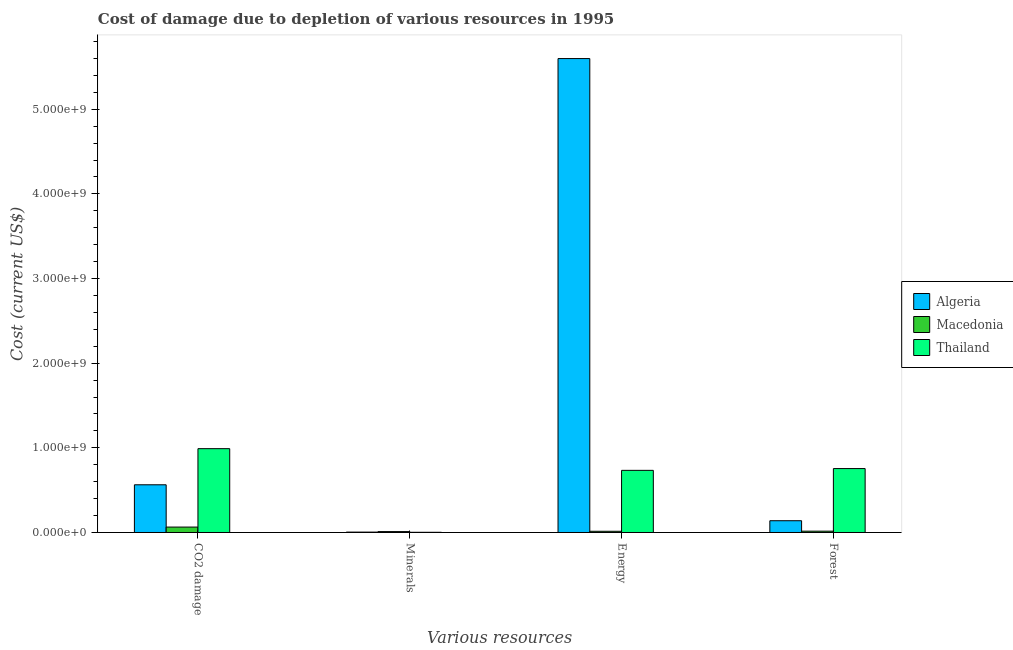How many different coloured bars are there?
Provide a succinct answer. 3. Are the number of bars per tick equal to the number of legend labels?
Your response must be concise. Yes. Are the number of bars on each tick of the X-axis equal?
Offer a very short reply. Yes. How many bars are there on the 4th tick from the right?
Offer a terse response. 3. What is the label of the 1st group of bars from the left?
Your answer should be very brief. CO2 damage. What is the cost of damage due to depletion of minerals in Algeria?
Give a very brief answer. 4.58e+06. Across all countries, what is the maximum cost of damage due to depletion of minerals?
Ensure brevity in your answer.  1.07e+07. Across all countries, what is the minimum cost of damage due to depletion of minerals?
Your response must be concise. 2.41e+06. In which country was the cost of damage due to depletion of minerals maximum?
Offer a terse response. Macedonia. In which country was the cost of damage due to depletion of energy minimum?
Your response must be concise. Macedonia. What is the total cost of damage due to depletion of minerals in the graph?
Provide a short and direct response. 1.76e+07. What is the difference between the cost of damage due to depletion of forests in Thailand and that in Algeria?
Provide a short and direct response. 6.16e+08. What is the difference between the cost of damage due to depletion of energy in Thailand and the cost of damage due to depletion of coal in Algeria?
Offer a terse response. 1.71e+08. What is the average cost of damage due to depletion of minerals per country?
Offer a very short reply. 5.88e+06. What is the difference between the cost of damage due to depletion of coal and cost of damage due to depletion of minerals in Thailand?
Keep it short and to the point. 9.88e+08. What is the ratio of the cost of damage due to depletion of minerals in Thailand to that in Algeria?
Your response must be concise. 0.53. Is the difference between the cost of damage due to depletion of minerals in Algeria and Macedonia greater than the difference between the cost of damage due to depletion of energy in Algeria and Macedonia?
Provide a short and direct response. No. What is the difference between the highest and the second highest cost of damage due to depletion of minerals?
Your answer should be compact. 6.08e+06. What is the difference between the highest and the lowest cost of damage due to depletion of coal?
Your response must be concise. 9.26e+08. Is the sum of the cost of damage due to depletion of forests in Thailand and Macedonia greater than the maximum cost of damage due to depletion of minerals across all countries?
Offer a very short reply. Yes. What does the 3rd bar from the left in Forest represents?
Offer a terse response. Thailand. What does the 2nd bar from the right in Energy represents?
Provide a succinct answer. Macedonia. Are all the bars in the graph horizontal?
Provide a succinct answer. No. How many countries are there in the graph?
Offer a terse response. 3. Are the values on the major ticks of Y-axis written in scientific E-notation?
Your response must be concise. Yes. Where does the legend appear in the graph?
Ensure brevity in your answer.  Center right. What is the title of the graph?
Offer a very short reply. Cost of damage due to depletion of various resources in 1995 . Does "Solomon Islands" appear as one of the legend labels in the graph?
Your response must be concise. No. What is the label or title of the X-axis?
Keep it short and to the point. Various resources. What is the label or title of the Y-axis?
Offer a very short reply. Cost (current US$). What is the Cost (current US$) in Algeria in CO2 damage?
Make the answer very short. 5.63e+08. What is the Cost (current US$) of Macedonia in CO2 damage?
Your response must be concise. 6.41e+07. What is the Cost (current US$) in Thailand in CO2 damage?
Ensure brevity in your answer.  9.90e+08. What is the Cost (current US$) in Algeria in Minerals?
Keep it short and to the point. 4.58e+06. What is the Cost (current US$) of Macedonia in Minerals?
Provide a short and direct response. 1.07e+07. What is the Cost (current US$) of Thailand in Minerals?
Provide a succinct answer. 2.41e+06. What is the Cost (current US$) in Algeria in Energy?
Ensure brevity in your answer.  5.60e+09. What is the Cost (current US$) of Macedonia in Energy?
Provide a short and direct response. 1.43e+07. What is the Cost (current US$) of Thailand in Energy?
Provide a short and direct response. 7.34e+08. What is the Cost (current US$) of Algeria in Forest?
Your answer should be compact. 1.39e+08. What is the Cost (current US$) of Macedonia in Forest?
Ensure brevity in your answer.  1.57e+07. What is the Cost (current US$) of Thailand in Forest?
Your answer should be compact. 7.55e+08. Across all Various resources, what is the maximum Cost (current US$) in Algeria?
Your answer should be very brief. 5.60e+09. Across all Various resources, what is the maximum Cost (current US$) in Macedonia?
Give a very brief answer. 6.41e+07. Across all Various resources, what is the maximum Cost (current US$) in Thailand?
Make the answer very short. 9.90e+08. Across all Various resources, what is the minimum Cost (current US$) in Algeria?
Provide a succinct answer. 4.58e+06. Across all Various resources, what is the minimum Cost (current US$) of Macedonia?
Provide a succinct answer. 1.07e+07. Across all Various resources, what is the minimum Cost (current US$) of Thailand?
Make the answer very short. 2.41e+06. What is the total Cost (current US$) in Algeria in the graph?
Your answer should be compact. 6.31e+09. What is the total Cost (current US$) in Macedonia in the graph?
Your answer should be compact. 1.05e+08. What is the total Cost (current US$) of Thailand in the graph?
Keep it short and to the point. 2.48e+09. What is the difference between the Cost (current US$) of Algeria in CO2 damage and that in Minerals?
Ensure brevity in your answer.  5.59e+08. What is the difference between the Cost (current US$) in Macedonia in CO2 damage and that in Minerals?
Offer a terse response. 5.34e+07. What is the difference between the Cost (current US$) of Thailand in CO2 damage and that in Minerals?
Your answer should be very brief. 9.88e+08. What is the difference between the Cost (current US$) of Algeria in CO2 damage and that in Energy?
Offer a terse response. -5.04e+09. What is the difference between the Cost (current US$) in Macedonia in CO2 damage and that in Energy?
Keep it short and to the point. 4.98e+07. What is the difference between the Cost (current US$) in Thailand in CO2 damage and that in Energy?
Your response must be concise. 2.56e+08. What is the difference between the Cost (current US$) in Algeria in CO2 damage and that in Forest?
Your response must be concise. 4.24e+08. What is the difference between the Cost (current US$) in Macedonia in CO2 damage and that in Forest?
Offer a very short reply. 4.84e+07. What is the difference between the Cost (current US$) in Thailand in CO2 damage and that in Forest?
Keep it short and to the point. 2.35e+08. What is the difference between the Cost (current US$) in Algeria in Minerals and that in Energy?
Your answer should be very brief. -5.59e+09. What is the difference between the Cost (current US$) of Macedonia in Minerals and that in Energy?
Your response must be concise. -3.61e+06. What is the difference between the Cost (current US$) of Thailand in Minerals and that in Energy?
Ensure brevity in your answer.  -7.32e+08. What is the difference between the Cost (current US$) in Algeria in Minerals and that in Forest?
Keep it short and to the point. -1.34e+08. What is the difference between the Cost (current US$) of Macedonia in Minerals and that in Forest?
Make the answer very short. -5.00e+06. What is the difference between the Cost (current US$) of Thailand in Minerals and that in Forest?
Make the answer very short. -7.53e+08. What is the difference between the Cost (current US$) of Algeria in Energy and that in Forest?
Your response must be concise. 5.46e+09. What is the difference between the Cost (current US$) in Macedonia in Energy and that in Forest?
Make the answer very short. -1.39e+06. What is the difference between the Cost (current US$) in Thailand in Energy and that in Forest?
Keep it short and to the point. -2.10e+07. What is the difference between the Cost (current US$) of Algeria in CO2 damage and the Cost (current US$) of Macedonia in Minerals?
Your answer should be compact. 5.53e+08. What is the difference between the Cost (current US$) of Algeria in CO2 damage and the Cost (current US$) of Thailand in Minerals?
Your answer should be compact. 5.61e+08. What is the difference between the Cost (current US$) of Macedonia in CO2 damage and the Cost (current US$) of Thailand in Minerals?
Ensure brevity in your answer.  6.16e+07. What is the difference between the Cost (current US$) in Algeria in CO2 damage and the Cost (current US$) in Macedonia in Energy?
Provide a short and direct response. 5.49e+08. What is the difference between the Cost (current US$) in Algeria in CO2 damage and the Cost (current US$) in Thailand in Energy?
Provide a short and direct response. -1.71e+08. What is the difference between the Cost (current US$) in Macedonia in CO2 damage and the Cost (current US$) in Thailand in Energy?
Offer a terse response. -6.70e+08. What is the difference between the Cost (current US$) of Algeria in CO2 damage and the Cost (current US$) of Macedonia in Forest?
Your response must be concise. 5.48e+08. What is the difference between the Cost (current US$) of Algeria in CO2 damage and the Cost (current US$) of Thailand in Forest?
Keep it short and to the point. -1.92e+08. What is the difference between the Cost (current US$) of Macedonia in CO2 damage and the Cost (current US$) of Thailand in Forest?
Offer a terse response. -6.91e+08. What is the difference between the Cost (current US$) of Algeria in Minerals and the Cost (current US$) of Macedonia in Energy?
Offer a very short reply. -9.69e+06. What is the difference between the Cost (current US$) in Algeria in Minerals and the Cost (current US$) in Thailand in Energy?
Your answer should be very brief. -7.29e+08. What is the difference between the Cost (current US$) in Macedonia in Minerals and the Cost (current US$) in Thailand in Energy?
Ensure brevity in your answer.  -7.23e+08. What is the difference between the Cost (current US$) of Algeria in Minerals and the Cost (current US$) of Macedonia in Forest?
Provide a short and direct response. -1.11e+07. What is the difference between the Cost (current US$) of Algeria in Minerals and the Cost (current US$) of Thailand in Forest?
Provide a succinct answer. -7.50e+08. What is the difference between the Cost (current US$) in Macedonia in Minerals and the Cost (current US$) in Thailand in Forest?
Ensure brevity in your answer.  -7.44e+08. What is the difference between the Cost (current US$) in Algeria in Energy and the Cost (current US$) in Macedonia in Forest?
Offer a terse response. 5.58e+09. What is the difference between the Cost (current US$) of Algeria in Energy and the Cost (current US$) of Thailand in Forest?
Provide a short and direct response. 4.84e+09. What is the difference between the Cost (current US$) in Macedonia in Energy and the Cost (current US$) in Thailand in Forest?
Your answer should be very brief. -7.41e+08. What is the average Cost (current US$) in Algeria per Various resources?
Your response must be concise. 1.58e+09. What is the average Cost (current US$) in Macedonia per Various resources?
Keep it short and to the point. 2.62e+07. What is the average Cost (current US$) in Thailand per Various resources?
Give a very brief answer. 6.20e+08. What is the difference between the Cost (current US$) in Algeria and Cost (current US$) in Macedonia in CO2 damage?
Your answer should be compact. 4.99e+08. What is the difference between the Cost (current US$) in Algeria and Cost (current US$) in Thailand in CO2 damage?
Provide a short and direct response. -4.27e+08. What is the difference between the Cost (current US$) of Macedonia and Cost (current US$) of Thailand in CO2 damage?
Provide a succinct answer. -9.26e+08. What is the difference between the Cost (current US$) of Algeria and Cost (current US$) of Macedonia in Minerals?
Provide a succinct answer. -6.08e+06. What is the difference between the Cost (current US$) in Algeria and Cost (current US$) in Thailand in Minerals?
Offer a very short reply. 2.16e+06. What is the difference between the Cost (current US$) of Macedonia and Cost (current US$) of Thailand in Minerals?
Offer a terse response. 8.25e+06. What is the difference between the Cost (current US$) in Algeria and Cost (current US$) in Macedonia in Energy?
Ensure brevity in your answer.  5.58e+09. What is the difference between the Cost (current US$) of Algeria and Cost (current US$) of Thailand in Energy?
Your answer should be compact. 4.86e+09. What is the difference between the Cost (current US$) in Macedonia and Cost (current US$) in Thailand in Energy?
Offer a very short reply. -7.20e+08. What is the difference between the Cost (current US$) in Algeria and Cost (current US$) in Macedonia in Forest?
Your answer should be very brief. 1.23e+08. What is the difference between the Cost (current US$) of Algeria and Cost (current US$) of Thailand in Forest?
Make the answer very short. -6.16e+08. What is the difference between the Cost (current US$) in Macedonia and Cost (current US$) in Thailand in Forest?
Make the answer very short. -7.39e+08. What is the ratio of the Cost (current US$) of Algeria in CO2 damage to that in Minerals?
Keep it short and to the point. 123.15. What is the ratio of the Cost (current US$) in Macedonia in CO2 damage to that in Minerals?
Ensure brevity in your answer.  6.01. What is the ratio of the Cost (current US$) in Thailand in CO2 damage to that in Minerals?
Your answer should be very brief. 410.63. What is the ratio of the Cost (current US$) of Algeria in CO2 damage to that in Energy?
Provide a succinct answer. 0.1. What is the ratio of the Cost (current US$) in Macedonia in CO2 damage to that in Energy?
Make the answer very short. 4.49. What is the ratio of the Cost (current US$) of Thailand in CO2 damage to that in Energy?
Give a very brief answer. 1.35. What is the ratio of the Cost (current US$) in Algeria in CO2 damage to that in Forest?
Your response must be concise. 4.05. What is the ratio of the Cost (current US$) of Macedonia in CO2 damage to that in Forest?
Give a very brief answer. 4.09. What is the ratio of the Cost (current US$) in Thailand in CO2 damage to that in Forest?
Your answer should be very brief. 1.31. What is the ratio of the Cost (current US$) in Algeria in Minerals to that in Energy?
Give a very brief answer. 0. What is the ratio of the Cost (current US$) of Macedonia in Minerals to that in Energy?
Provide a short and direct response. 0.75. What is the ratio of the Cost (current US$) in Thailand in Minerals to that in Energy?
Provide a short and direct response. 0. What is the ratio of the Cost (current US$) in Algeria in Minerals to that in Forest?
Give a very brief answer. 0.03. What is the ratio of the Cost (current US$) of Macedonia in Minerals to that in Forest?
Provide a succinct answer. 0.68. What is the ratio of the Cost (current US$) in Thailand in Minerals to that in Forest?
Your answer should be very brief. 0. What is the ratio of the Cost (current US$) of Algeria in Energy to that in Forest?
Provide a succinct answer. 40.28. What is the ratio of the Cost (current US$) in Macedonia in Energy to that in Forest?
Keep it short and to the point. 0.91. What is the ratio of the Cost (current US$) of Thailand in Energy to that in Forest?
Provide a succinct answer. 0.97. What is the difference between the highest and the second highest Cost (current US$) of Algeria?
Offer a terse response. 5.04e+09. What is the difference between the highest and the second highest Cost (current US$) in Macedonia?
Your answer should be compact. 4.84e+07. What is the difference between the highest and the second highest Cost (current US$) of Thailand?
Provide a succinct answer. 2.35e+08. What is the difference between the highest and the lowest Cost (current US$) of Algeria?
Make the answer very short. 5.59e+09. What is the difference between the highest and the lowest Cost (current US$) of Macedonia?
Provide a succinct answer. 5.34e+07. What is the difference between the highest and the lowest Cost (current US$) in Thailand?
Make the answer very short. 9.88e+08. 